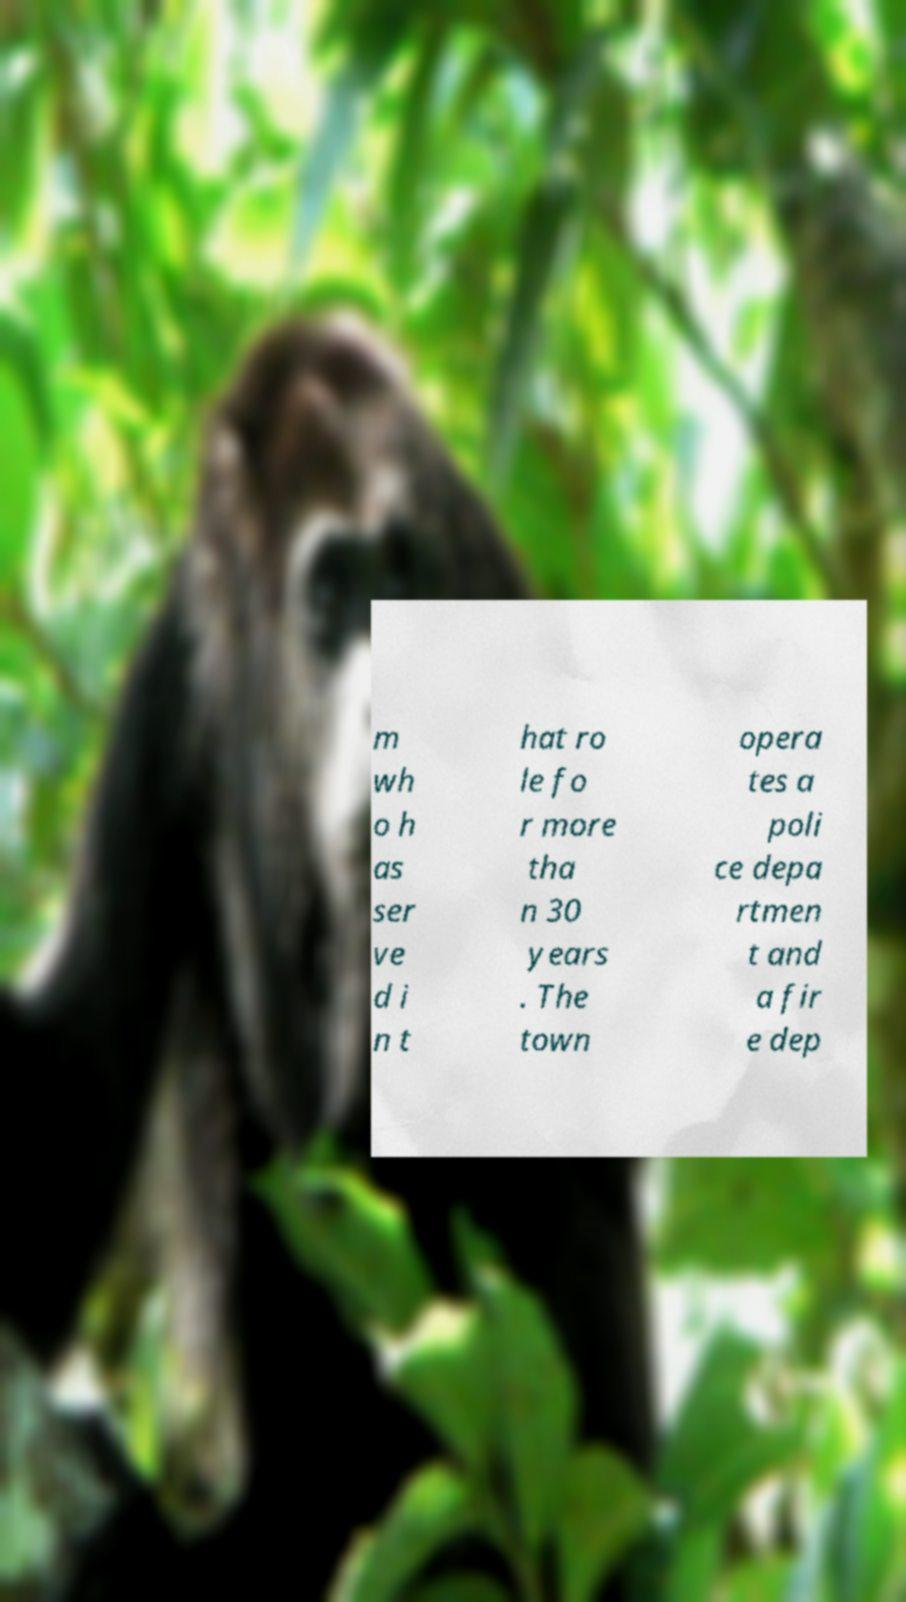I need the written content from this picture converted into text. Can you do that? m wh o h as ser ve d i n t hat ro le fo r more tha n 30 years . The town opera tes a poli ce depa rtmen t and a fir e dep 